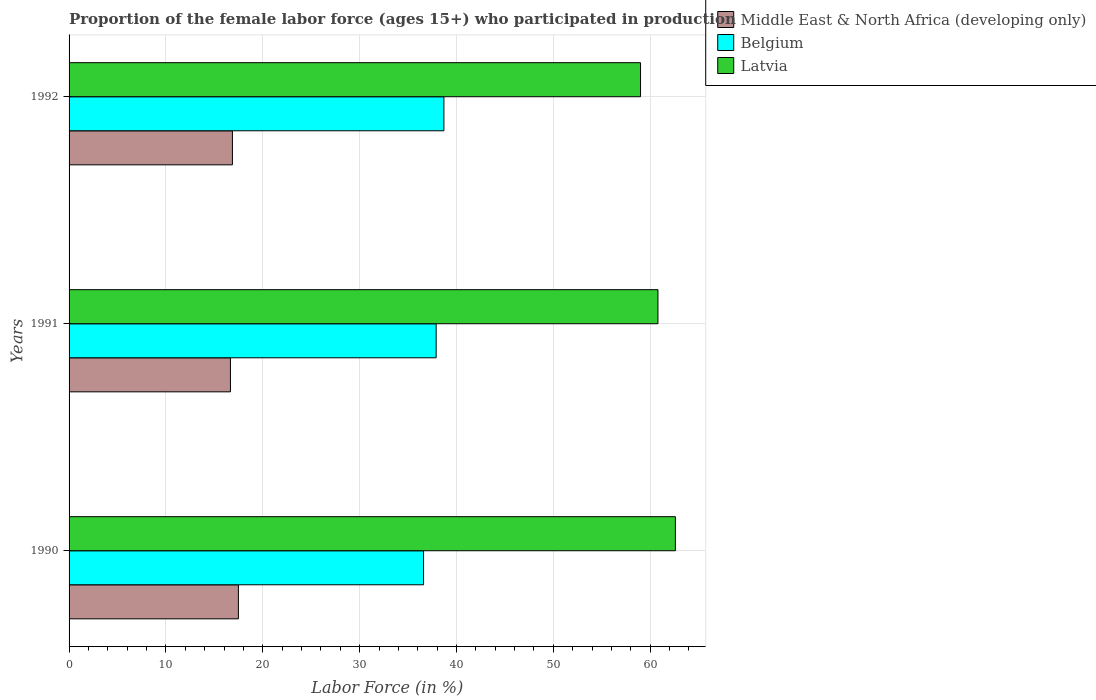How many groups of bars are there?
Your response must be concise. 3. How many bars are there on the 1st tick from the bottom?
Make the answer very short. 3. In how many cases, is the number of bars for a given year not equal to the number of legend labels?
Your answer should be compact. 0. What is the proportion of the female labor force who participated in production in Middle East & North Africa (developing only) in 1990?
Your answer should be compact. 17.48. Across all years, what is the maximum proportion of the female labor force who participated in production in Middle East & North Africa (developing only)?
Your response must be concise. 17.48. Across all years, what is the minimum proportion of the female labor force who participated in production in Belgium?
Offer a terse response. 36.6. In which year was the proportion of the female labor force who participated in production in Latvia maximum?
Your answer should be compact. 1990. In which year was the proportion of the female labor force who participated in production in Latvia minimum?
Offer a very short reply. 1992. What is the total proportion of the female labor force who participated in production in Latvia in the graph?
Keep it short and to the point. 182.4. What is the difference between the proportion of the female labor force who participated in production in Belgium in 1991 and that in 1992?
Give a very brief answer. -0.8. What is the difference between the proportion of the female labor force who participated in production in Latvia in 1990 and the proportion of the female labor force who participated in production in Belgium in 1991?
Make the answer very short. 24.7. What is the average proportion of the female labor force who participated in production in Middle East & North Africa (developing only) per year?
Your response must be concise. 17. In the year 1992, what is the difference between the proportion of the female labor force who participated in production in Belgium and proportion of the female labor force who participated in production in Middle East & North Africa (developing only)?
Provide a short and direct response. 21.83. In how many years, is the proportion of the female labor force who participated in production in Belgium greater than 32 %?
Provide a short and direct response. 3. What is the ratio of the proportion of the female labor force who participated in production in Middle East & North Africa (developing only) in 1991 to that in 1992?
Keep it short and to the point. 0.99. Is the difference between the proportion of the female labor force who participated in production in Belgium in 1990 and 1992 greater than the difference between the proportion of the female labor force who participated in production in Middle East & North Africa (developing only) in 1990 and 1992?
Provide a short and direct response. No. What is the difference between the highest and the second highest proportion of the female labor force who participated in production in Belgium?
Give a very brief answer. 0.8. What is the difference between the highest and the lowest proportion of the female labor force who participated in production in Latvia?
Provide a succinct answer. 3.6. What does the 1st bar from the top in 1990 represents?
Offer a terse response. Latvia. What does the 3rd bar from the bottom in 1991 represents?
Give a very brief answer. Latvia. How many bars are there?
Give a very brief answer. 9. How many years are there in the graph?
Make the answer very short. 3. What is the difference between two consecutive major ticks on the X-axis?
Your answer should be very brief. 10. Are the values on the major ticks of X-axis written in scientific E-notation?
Your answer should be compact. No. Does the graph contain any zero values?
Provide a succinct answer. No. Does the graph contain grids?
Provide a succinct answer. Yes. Where does the legend appear in the graph?
Give a very brief answer. Top right. What is the title of the graph?
Provide a succinct answer. Proportion of the female labor force (ages 15+) who participated in production. Does "Kenya" appear as one of the legend labels in the graph?
Give a very brief answer. No. What is the Labor Force (in %) of Middle East & North Africa (developing only) in 1990?
Your response must be concise. 17.48. What is the Labor Force (in %) in Belgium in 1990?
Keep it short and to the point. 36.6. What is the Labor Force (in %) of Latvia in 1990?
Provide a short and direct response. 62.6. What is the Labor Force (in %) in Middle East & North Africa (developing only) in 1991?
Offer a terse response. 16.66. What is the Labor Force (in %) in Belgium in 1991?
Ensure brevity in your answer.  37.9. What is the Labor Force (in %) of Latvia in 1991?
Offer a very short reply. 60.8. What is the Labor Force (in %) of Middle East & North Africa (developing only) in 1992?
Keep it short and to the point. 16.87. What is the Labor Force (in %) in Belgium in 1992?
Your answer should be very brief. 38.7. What is the Labor Force (in %) in Latvia in 1992?
Your answer should be very brief. 59. Across all years, what is the maximum Labor Force (in %) in Middle East & North Africa (developing only)?
Make the answer very short. 17.48. Across all years, what is the maximum Labor Force (in %) in Belgium?
Offer a terse response. 38.7. Across all years, what is the maximum Labor Force (in %) of Latvia?
Offer a very short reply. 62.6. Across all years, what is the minimum Labor Force (in %) of Middle East & North Africa (developing only)?
Provide a short and direct response. 16.66. Across all years, what is the minimum Labor Force (in %) in Belgium?
Your answer should be very brief. 36.6. What is the total Labor Force (in %) in Middle East & North Africa (developing only) in the graph?
Keep it short and to the point. 51.01. What is the total Labor Force (in %) of Belgium in the graph?
Offer a very short reply. 113.2. What is the total Labor Force (in %) in Latvia in the graph?
Give a very brief answer. 182.4. What is the difference between the Labor Force (in %) of Middle East & North Africa (developing only) in 1990 and that in 1991?
Your response must be concise. 0.82. What is the difference between the Labor Force (in %) of Middle East & North Africa (developing only) in 1990 and that in 1992?
Give a very brief answer. 0.62. What is the difference between the Labor Force (in %) in Latvia in 1990 and that in 1992?
Your answer should be very brief. 3.6. What is the difference between the Labor Force (in %) of Middle East & North Africa (developing only) in 1991 and that in 1992?
Give a very brief answer. -0.21. What is the difference between the Labor Force (in %) of Belgium in 1991 and that in 1992?
Give a very brief answer. -0.8. What is the difference between the Labor Force (in %) in Latvia in 1991 and that in 1992?
Provide a succinct answer. 1.8. What is the difference between the Labor Force (in %) of Middle East & North Africa (developing only) in 1990 and the Labor Force (in %) of Belgium in 1991?
Your response must be concise. -20.42. What is the difference between the Labor Force (in %) in Middle East & North Africa (developing only) in 1990 and the Labor Force (in %) in Latvia in 1991?
Provide a short and direct response. -43.32. What is the difference between the Labor Force (in %) of Belgium in 1990 and the Labor Force (in %) of Latvia in 1991?
Offer a terse response. -24.2. What is the difference between the Labor Force (in %) in Middle East & North Africa (developing only) in 1990 and the Labor Force (in %) in Belgium in 1992?
Make the answer very short. -21.22. What is the difference between the Labor Force (in %) in Middle East & North Africa (developing only) in 1990 and the Labor Force (in %) in Latvia in 1992?
Make the answer very short. -41.52. What is the difference between the Labor Force (in %) of Belgium in 1990 and the Labor Force (in %) of Latvia in 1992?
Your answer should be very brief. -22.4. What is the difference between the Labor Force (in %) of Middle East & North Africa (developing only) in 1991 and the Labor Force (in %) of Belgium in 1992?
Offer a terse response. -22.04. What is the difference between the Labor Force (in %) of Middle East & North Africa (developing only) in 1991 and the Labor Force (in %) of Latvia in 1992?
Your answer should be very brief. -42.34. What is the difference between the Labor Force (in %) in Belgium in 1991 and the Labor Force (in %) in Latvia in 1992?
Your answer should be compact. -21.1. What is the average Labor Force (in %) of Middle East & North Africa (developing only) per year?
Your answer should be very brief. 17. What is the average Labor Force (in %) in Belgium per year?
Your response must be concise. 37.73. What is the average Labor Force (in %) in Latvia per year?
Ensure brevity in your answer.  60.8. In the year 1990, what is the difference between the Labor Force (in %) in Middle East & North Africa (developing only) and Labor Force (in %) in Belgium?
Your answer should be compact. -19.12. In the year 1990, what is the difference between the Labor Force (in %) in Middle East & North Africa (developing only) and Labor Force (in %) in Latvia?
Provide a short and direct response. -45.12. In the year 1991, what is the difference between the Labor Force (in %) in Middle East & North Africa (developing only) and Labor Force (in %) in Belgium?
Give a very brief answer. -21.24. In the year 1991, what is the difference between the Labor Force (in %) of Middle East & North Africa (developing only) and Labor Force (in %) of Latvia?
Your answer should be very brief. -44.14. In the year 1991, what is the difference between the Labor Force (in %) of Belgium and Labor Force (in %) of Latvia?
Provide a short and direct response. -22.9. In the year 1992, what is the difference between the Labor Force (in %) in Middle East & North Africa (developing only) and Labor Force (in %) in Belgium?
Offer a very short reply. -21.83. In the year 1992, what is the difference between the Labor Force (in %) of Middle East & North Africa (developing only) and Labor Force (in %) of Latvia?
Keep it short and to the point. -42.13. In the year 1992, what is the difference between the Labor Force (in %) in Belgium and Labor Force (in %) in Latvia?
Your answer should be very brief. -20.3. What is the ratio of the Labor Force (in %) in Middle East & North Africa (developing only) in 1990 to that in 1991?
Offer a terse response. 1.05. What is the ratio of the Labor Force (in %) of Belgium in 1990 to that in 1991?
Make the answer very short. 0.97. What is the ratio of the Labor Force (in %) in Latvia in 1990 to that in 1991?
Your answer should be very brief. 1.03. What is the ratio of the Labor Force (in %) of Middle East & North Africa (developing only) in 1990 to that in 1992?
Your answer should be compact. 1.04. What is the ratio of the Labor Force (in %) in Belgium in 1990 to that in 1992?
Your answer should be very brief. 0.95. What is the ratio of the Labor Force (in %) of Latvia in 1990 to that in 1992?
Provide a succinct answer. 1.06. What is the ratio of the Labor Force (in %) in Belgium in 1991 to that in 1992?
Your answer should be very brief. 0.98. What is the ratio of the Labor Force (in %) of Latvia in 1991 to that in 1992?
Give a very brief answer. 1.03. What is the difference between the highest and the second highest Labor Force (in %) of Middle East & North Africa (developing only)?
Ensure brevity in your answer.  0.62. What is the difference between the highest and the second highest Labor Force (in %) of Latvia?
Your response must be concise. 1.8. What is the difference between the highest and the lowest Labor Force (in %) in Middle East & North Africa (developing only)?
Keep it short and to the point. 0.82. What is the difference between the highest and the lowest Labor Force (in %) in Latvia?
Your answer should be very brief. 3.6. 